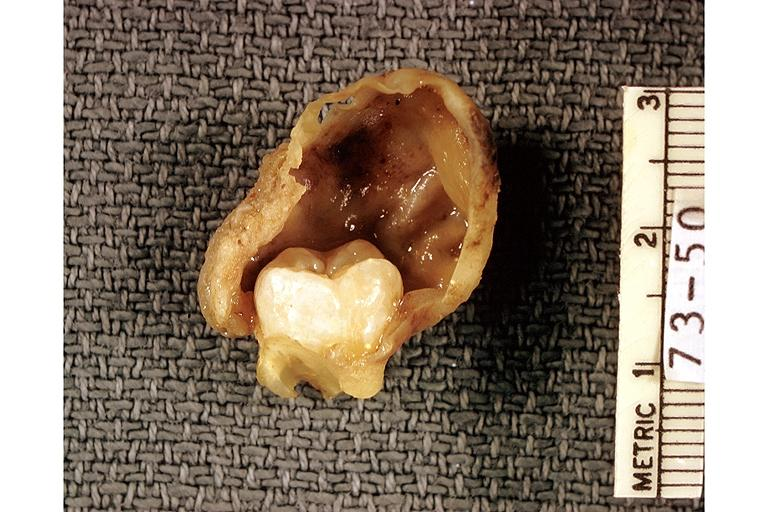where is this?
Answer the question using a single word or phrase. Oral 